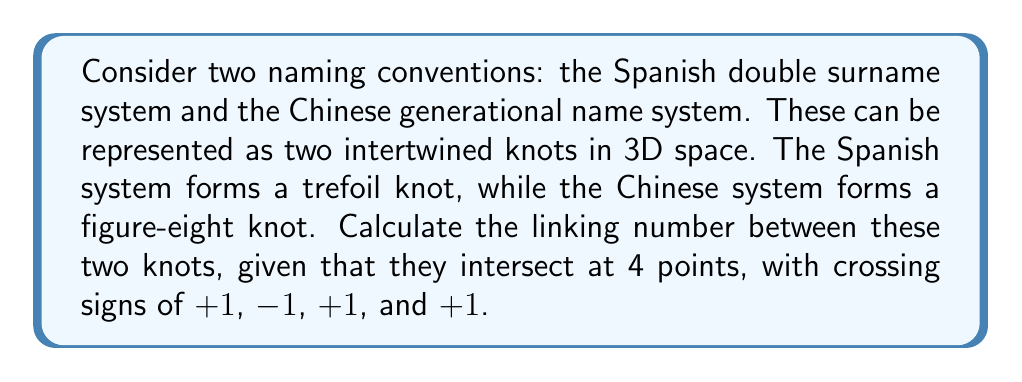Can you solve this math problem? To calculate the linking number between two knots, we follow these steps:

1) The linking number is defined as half the sum of the crossing signs at all intersection points:

   $$ \text{Linking Number} = \frac{1}{2} \sum_{i=1}^{n} \epsilon_i $$

   where $\epsilon_i$ is the sign of the $i$-th crossing (+1 for positive, -1 for negative).

2) In this case, we have 4 intersection points with the following signs:
   $\epsilon_1 = +1$
   $\epsilon_2 = -1$
   $\epsilon_3 = +1$
   $\epsilon_4 = +1$

3) Sum these crossing signs:

   $$ \sum_{i=1}^{4} \epsilon_i = (+1) + (-1) + (+1) + (+1) = 2 $$

4) Divide the sum by 2 to get the linking number:

   $$ \text{Linking Number} = \frac{1}{2} (2) = 1 $$

Therefore, the linking number between the Spanish double surname system (trefoil knot) and the Chinese generational name system (figure-eight knot) is 1.
Answer: 1 